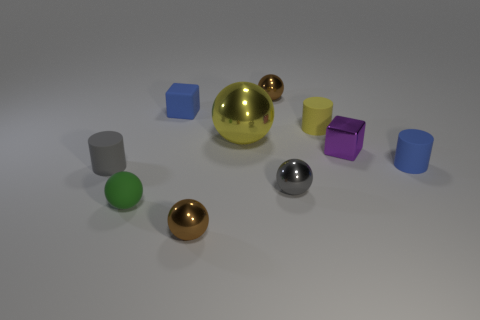Subtract all yellow balls. How many balls are left? 4 Subtract all tiny rubber balls. How many balls are left? 4 Subtract all red balls. Subtract all purple cylinders. How many balls are left? 5 Subtract all cylinders. How many objects are left? 7 Add 5 big metal spheres. How many big metal spheres are left? 6 Add 5 small yellow matte things. How many small yellow matte things exist? 6 Subtract 1 gray balls. How many objects are left? 9 Subtract all gray cylinders. Subtract all small brown metal spheres. How many objects are left? 7 